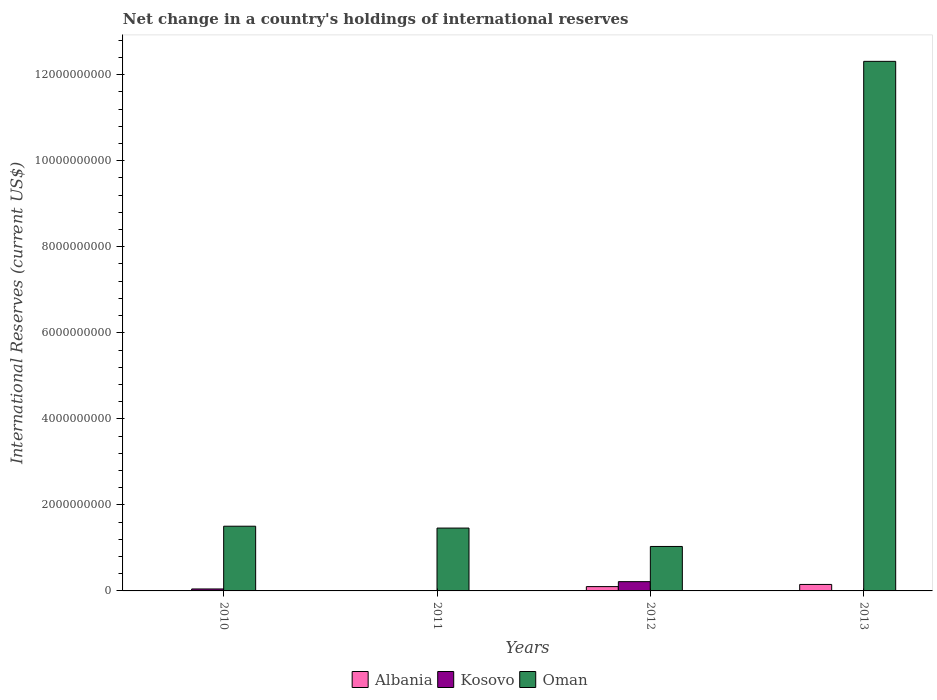Are the number of bars per tick equal to the number of legend labels?
Offer a very short reply. No. How many bars are there on the 4th tick from the right?
Offer a terse response. 2. What is the international reserves in Oman in 2010?
Your response must be concise. 1.50e+09. Across all years, what is the maximum international reserves in Albania?
Offer a very short reply. 1.51e+08. Across all years, what is the minimum international reserves in Albania?
Your answer should be very brief. 0. What is the total international reserves in Kosovo in the graph?
Offer a very short reply. 2.61e+08. What is the difference between the international reserves in Oman in 2011 and that in 2012?
Your answer should be very brief. 4.28e+08. What is the difference between the international reserves in Kosovo in 2010 and the international reserves in Oman in 2013?
Provide a short and direct response. -1.23e+1. What is the average international reserves in Kosovo per year?
Provide a short and direct response. 6.53e+07. In the year 2013, what is the difference between the international reserves in Oman and international reserves in Albania?
Ensure brevity in your answer.  1.22e+1. What is the ratio of the international reserves in Oman in 2011 to that in 2013?
Give a very brief answer. 0.12. Is the international reserves in Albania in 2012 less than that in 2013?
Keep it short and to the point. Yes. What is the difference between the highest and the second highest international reserves in Oman?
Your response must be concise. 1.08e+1. What is the difference between the highest and the lowest international reserves in Oman?
Offer a terse response. 1.13e+1. In how many years, is the international reserves in Oman greater than the average international reserves in Oman taken over all years?
Offer a terse response. 1. Is it the case that in every year, the sum of the international reserves in Albania and international reserves in Oman is greater than the international reserves in Kosovo?
Give a very brief answer. Yes. How many years are there in the graph?
Offer a terse response. 4. What is the difference between two consecutive major ticks on the Y-axis?
Your response must be concise. 2.00e+09. Are the values on the major ticks of Y-axis written in scientific E-notation?
Keep it short and to the point. No. Does the graph contain any zero values?
Give a very brief answer. Yes. How are the legend labels stacked?
Your response must be concise. Horizontal. What is the title of the graph?
Ensure brevity in your answer.  Net change in a country's holdings of international reserves. Does "Guatemala" appear as one of the legend labels in the graph?
Your response must be concise. No. What is the label or title of the X-axis?
Ensure brevity in your answer.  Years. What is the label or title of the Y-axis?
Make the answer very short. International Reserves (current US$). What is the International Reserves (current US$) in Kosovo in 2010?
Offer a very short reply. 4.57e+07. What is the International Reserves (current US$) of Oman in 2010?
Provide a succinct answer. 1.50e+09. What is the International Reserves (current US$) in Oman in 2011?
Give a very brief answer. 1.46e+09. What is the International Reserves (current US$) in Albania in 2012?
Your response must be concise. 1.00e+08. What is the International Reserves (current US$) in Kosovo in 2012?
Offer a very short reply. 2.16e+08. What is the International Reserves (current US$) in Oman in 2012?
Ensure brevity in your answer.  1.03e+09. What is the International Reserves (current US$) of Albania in 2013?
Make the answer very short. 1.51e+08. What is the International Reserves (current US$) of Kosovo in 2013?
Give a very brief answer. 0. What is the International Reserves (current US$) of Oman in 2013?
Provide a succinct answer. 1.23e+1. Across all years, what is the maximum International Reserves (current US$) in Albania?
Offer a very short reply. 1.51e+08. Across all years, what is the maximum International Reserves (current US$) of Kosovo?
Offer a very short reply. 2.16e+08. Across all years, what is the maximum International Reserves (current US$) in Oman?
Your answer should be very brief. 1.23e+1. Across all years, what is the minimum International Reserves (current US$) in Kosovo?
Ensure brevity in your answer.  0. Across all years, what is the minimum International Reserves (current US$) in Oman?
Your response must be concise. 1.03e+09. What is the total International Reserves (current US$) in Albania in the graph?
Keep it short and to the point. 2.51e+08. What is the total International Reserves (current US$) in Kosovo in the graph?
Make the answer very short. 2.61e+08. What is the total International Reserves (current US$) of Oman in the graph?
Give a very brief answer. 1.63e+1. What is the difference between the International Reserves (current US$) in Oman in 2010 and that in 2011?
Offer a very short reply. 4.31e+07. What is the difference between the International Reserves (current US$) of Kosovo in 2010 and that in 2012?
Give a very brief answer. -1.70e+08. What is the difference between the International Reserves (current US$) in Oman in 2010 and that in 2012?
Keep it short and to the point. 4.71e+08. What is the difference between the International Reserves (current US$) of Oman in 2010 and that in 2013?
Your response must be concise. -1.08e+1. What is the difference between the International Reserves (current US$) in Oman in 2011 and that in 2012?
Your response must be concise. 4.28e+08. What is the difference between the International Reserves (current US$) in Oman in 2011 and that in 2013?
Provide a succinct answer. -1.08e+1. What is the difference between the International Reserves (current US$) of Albania in 2012 and that in 2013?
Give a very brief answer. -5.01e+07. What is the difference between the International Reserves (current US$) of Oman in 2012 and that in 2013?
Your answer should be compact. -1.13e+1. What is the difference between the International Reserves (current US$) in Kosovo in 2010 and the International Reserves (current US$) in Oman in 2011?
Ensure brevity in your answer.  -1.42e+09. What is the difference between the International Reserves (current US$) in Kosovo in 2010 and the International Reserves (current US$) in Oman in 2012?
Offer a terse response. -9.88e+08. What is the difference between the International Reserves (current US$) in Kosovo in 2010 and the International Reserves (current US$) in Oman in 2013?
Offer a terse response. -1.23e+1. What is the difference between the International Reserves (current US$) of Albania in 2012 and the International Reserves (current US$) of Oman in 2013?
Offer a terse response. -1.22e+1. What is the difference between the International Reserves (current US$) in Kosovo in 2012 and the International Reserves (current US$) in Oman in 2013?
Keep it short and to the point. -1.21e+1. What is the average International Reserves (current US$) in Albania per year?
Offer a very short reply. 6.27e+07. What is the average International Reserves (current US$) in Kosovo per year?
Ensure brevity in your answer.  6.53e+07. What is the average International Reserves (current US$) of Oman per year?
Your response must be concise. 4.08e+09. In the year 2010, what is the difference between the International Reserves (current US$) of Kosovo and International Reserves (current US$) of Oman?
Ensure brevity in your answer.  -1.46e+09. In the year 2012, what is the difference between the International Reserves (current US$) in Albania and International Reserves (current US$) in Kosovo?
Provide a succinct answer. -1.15e+08. In the year 2012, what is the difference between the International Reserves (current US$) in Albania and International Reserves (current US$) in Oman?
Make the answer very short. -9.33e+08. In the year 2012, what is the difference between the International Reserves (current US$) in Kosovo and International Reserves (current US$) in Oman?
Offer a very short reply. -8.18e+08. In the year 2013, what is the difference between the International Reserves (current US$) in Albania and International Reserves (current US$) in Oman?
Your response must be concise. -1.22e+1. What is the ratio of the International Reserves (current US$) of Oman in 2010 to that in 2011?
Offer a terse response. 1.03. What is the ratio of the International Reserves (current US$) in Kosovo in 2010 to that in 2012?
Your answer should be very brief. 0.21. What is the ratio of the International Reserves (current US$) of Oman in 2010 to that in 2012?
Ensure brevity in your answer.  1.46. What is the ratio of the International Reserves (current US$) in Oman in 2010 to that in 2013?
Your answer should be very brief. 0.12. What is the ratio of the International Reserves (current US$) of Oman in 2011 to that in 2012?
Offer a terse response. 1.41. What is the ratio of the International Reserves (current US$) in Oman in 2011 to that in 2013?
Provide a succinct answer. 0.12. What is the ratio of the International Reserves (current US$) of Albania in 2012 to that in 2013?
Offer a terse response. 0.67. What is the ratio of the International Reserves (current US$) of Oman in 2012 to that in 2013?
Your response must be concise. 0.08. What is the difference between the highest and the second highest International Reserves (current US$) in Oman?
Your response must be concise. 1.08e+1. What is the difference between the highest and the lowest International Reserves (current US$) in Albania?
Offer a terse response. 1.51e+08. What is the difference between the highest and the lowest International Reserves (current US$) in Kosovo?
Your answer should be very brief. 2.16e+08. What is the difference between the highest and the lowest International Reserves (current US$) in Oman?
Provide a short and direct response. 1.13e+1. 